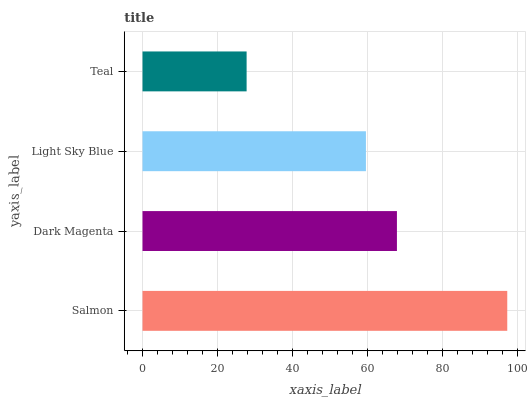Is Teal the minimum?
Answer yes or no. Yes. Is Salmon the maximum?
Answer yes or no. Yes. Is Dark Magenta the minimum?
Answer yes or no. No. Is Dark Magenta the maximum?
Answer yes or no. No. Is Salmon greater than Dark Magenta?
Answer yes or no. Yes. Is Dark Magenta less than Salmon?
Answer yes or no. Yes. Is Dark Magenta greater than Salmon?
Answer yes or no. No. Is Salmon less than Dark Magenta?
Answer yes or no. No. Is Dark Magenta the high median?
Answer yes or no. Yes. Is Light Sky Blue the low median?
Answer yes or no. Yes. Is Teal the high median?
Answer yes or no. No. Is Salmon the low median?
Answer yes or no. No. 